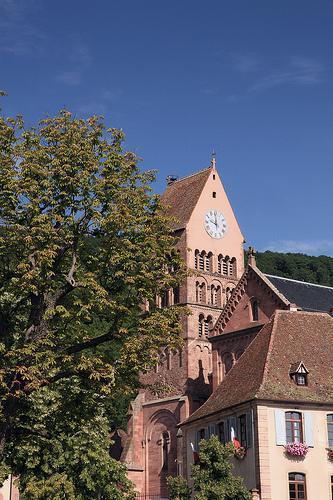How many clocks are there?
Give a very brief answer. 1. 